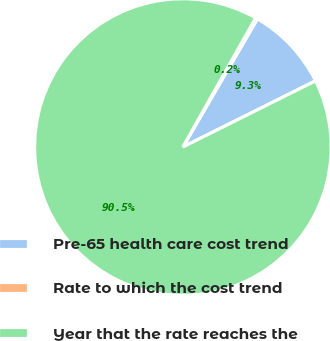<chart> <loc_0><loc_0><loc_500><loc_500><pie_chart><fcel>Pre-65 health care cost trend<fcel>Rate to which the cost trend<fcel>Year that the rate reaches the<nl><fcel>9.25%<fcel>0.22%<fcel>90.52%<nl></chart> 